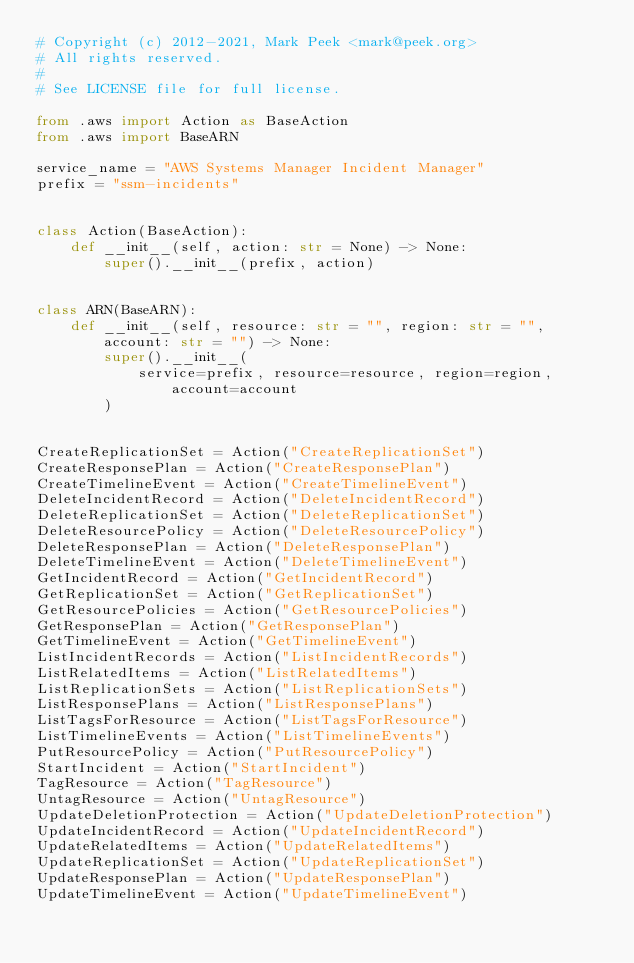<code> <loc_0><loc_0><loc_500><loc_500><_Python_># Copyright (c) 2012-2021, Mark Peek <mark@peek.org>
# All rights reserved.
#
# See LICENSE file for full license.

from .aws import Action as BaseAction
from .aws import BaseARN

service_name = "AWS Systems Manager Incident Manager"
prefix = "ssm-incidents"


class Action(BaseAction):
    def __init__(self, action: str = None) -> None:
        super().__init__(prefix, action)


class ARN(BaseARN):
    def __init__(self, resource: str = "", region: str = "", account: str = "") -> None:
        super().__init__(
            service=prefix, resource=resource, region=region, account=account
        )


CreateReplicationSet = Action("CreateReplicationSet")
CreateResponsePlan = Action("CreateResponsePlan")
CreateTimelineEvent = Action("CreateTimelineEvent")
DeleteIncidentRecord = Action("DeleteIncidentRecord")
DeleteReplicationSet = Action("DeleteReplicationSet")
DeleteResourcePolicy = Action("DeleteResourcePolicy")
DeleteResponsePlan = Action("DeleteResponsePlan")
DeleteTimelineEvent = Action("DeleteTimelineEvent")
GetIncidentRecord = Action("GetIncidentRecord")
GetReplicationSet = Action("GetReplicationSet")
GetResourcePolicies = Action("GetResourcePolicies")
GetResponsePlan = Action("GetResponsePlan")
GetTimelineEvent = Action("GetTimelineEvent")
ListIncidentRecords = Action("ListIncidentRecords")
ListRelatedItems = Action("ListRelatedItems")
ListReplicationSets = Action("ListReplicationSets")
ListResponsePlans = Action("ListResponsePlans")
ListTagsForResource = Action("ListTagsForResource")
ListTimelineEvents = Action("ListTimelineEvents")
PutResourcePolicy = Action("PutResourcePolicy")
StartIncident = Action("StartIncident")
TagResource = Action("TagResource")
UntagResource = Action("UntagResource")
UpdateDeletionProtection = Action("UpdateDeletionProtection")
UpdateIncidentRecord = Action("UpdateIncidentRecord")
UpdateRelatedItems = Action("UpdateRelatedItems")
UpdateReplicationSet = Action("UpdateReplicationSet")
UpdateResponsePlan = Action("UpdateResponsePlan")
UpdateTimelineEvent = Action("UpdateTimelineEvent")
</code> 